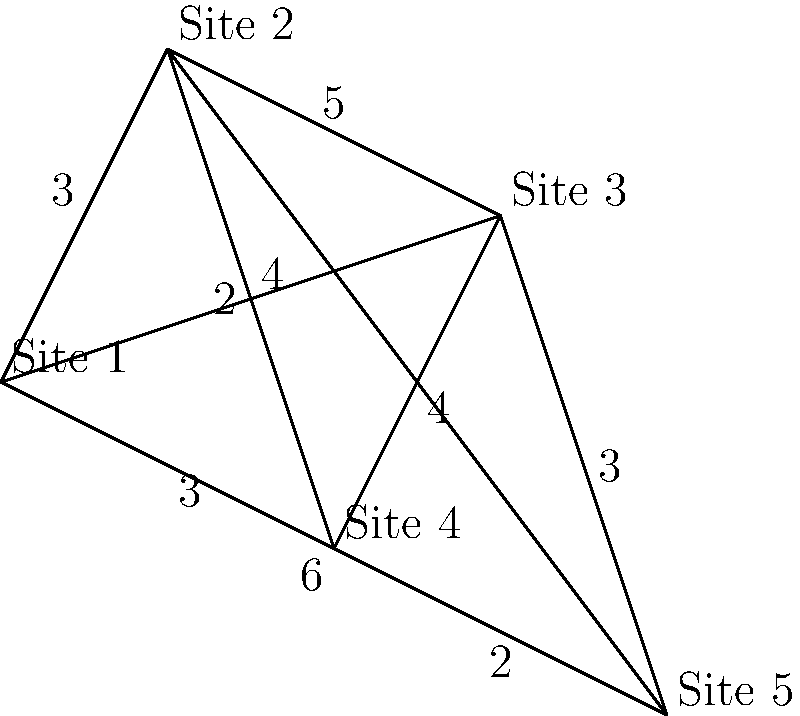As an archivist planning a preservation tour, you need to visit all five historical sites shown on the map, starting and ending at Site 1. Each edge represents a road connecting two sites, with the number indicating the travel time in hours. What is the shortest possible route that visits all sites exactly once and returns to Site 1, known as the Traveling Salesman Problem (TSP) solution? To solve this Traveling Salesman Problem, we need to consider all possible Hamiltonian cycles (paths that visit each vertex exactly once and return to the starting point) and find the one with the smallest total weight. Here's a step-by-step approach:

1. List all possible Hamiltonian cycles starting and ending at Site 1:
   a. 1-2-3-4-5-1
   b. 1-2-3-5-4-1
   c. 1-2-4-3-5-1
   d. 1-2-4-5-3-1
   e. 1-2-5-3-4-1
   f. 1-2-5-4-3-1
   g. 1-3-2-4-5-1
   h. 1-3-2-5-4-1
   i. 1-3-4-2-5-1
   j. 1-3-4-5-2-1
   k. 1-3-5-2-4-1
   l. 1-3-5-4-2-1

2. Calculate the total weight (time) for each cycle:
   a. 1-2-3-4-5-1: 3 + 5 + 4 + 2 + 6 = 20
   b. 1-2-3-5-4-1: 3 + 5 + 3 + 2 + 3 = 16
   c. 1-2-4-3-5-1: 3 + 2 + 4 + 3 + 6 = 18
   d. 1-2-4-5-3-1: 3 + 2 + 2 + 3 + 4 = 14
   e. 1-2-5-3-4-1: 3 + 4 + 3 + 4 + 3 = 17
   f. 1-2-5-4-3-1: 3 + 4 + 2 + 4 + 4 = 17
   g. 1-3-2-4-5-1: 4 + 5 + 2 + 2 + 6 = 19
   h. 1-3-2-5-4-1: 4 + 5 + 4 + 2 + 3 = 18
   i. 1-3-4-2-5-1: 4 + 4 + 2 + 4 + 6 = 20
   j. 1-3-4-5-2-1: 4 + 4 + 2 + 4 + 3 = 17
   k. 1-3-5-2-4-1: 4 + 3 + 4 + 2 + 3 = 16
   l. 1-3-5-4-2-1: 4 + 3 + 2 + 2 + 3 = 14

3. Identify the cycle(s) with the smallest total weight:
   The shortest cycles are d. 1-2-4-5-3-1 and l. 1-3-5-4-2-1, both with a total time of 14 hours.

4. Choose one of the shortest cycles as the optimal solution:
   We'll select 1-2-4-5-3-1 as our solution.

Therefore, the shortest possible route visiting all sites exactly once and returning to Site 1 is 1-2-4-5-3-1, with a total travel time of 14 hours.
Answer: 1-2-4-5-3-1 (14 hours) 